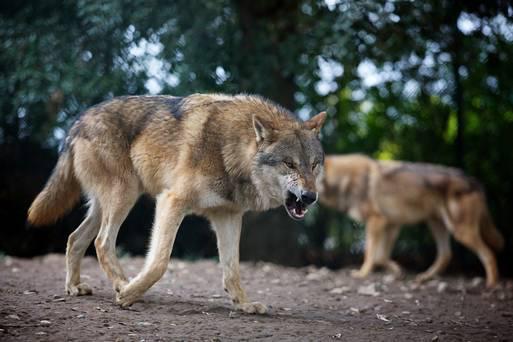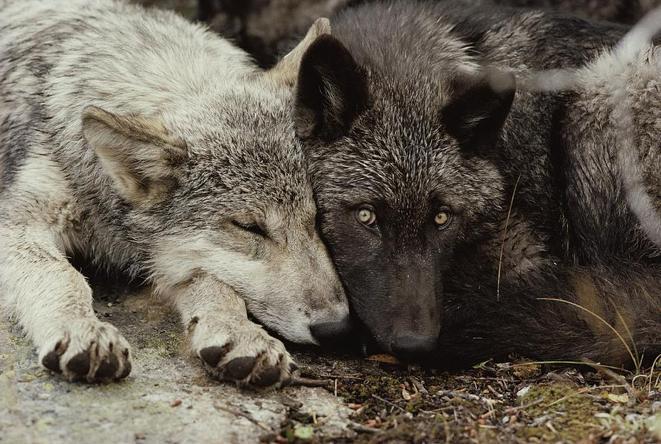The first image is the image on the left, the second image is the image on the right. Considering the images on both sides, is "The dogs in the image on the left are in a snowy area." valid? Answer yes or no. No. The first image is the image on the left, the second image is the image on the right. Assess this claim about the two images: "An image includes an open-mouthed snarling wolf.". Correct or not? Answer yes or no. Yes. 